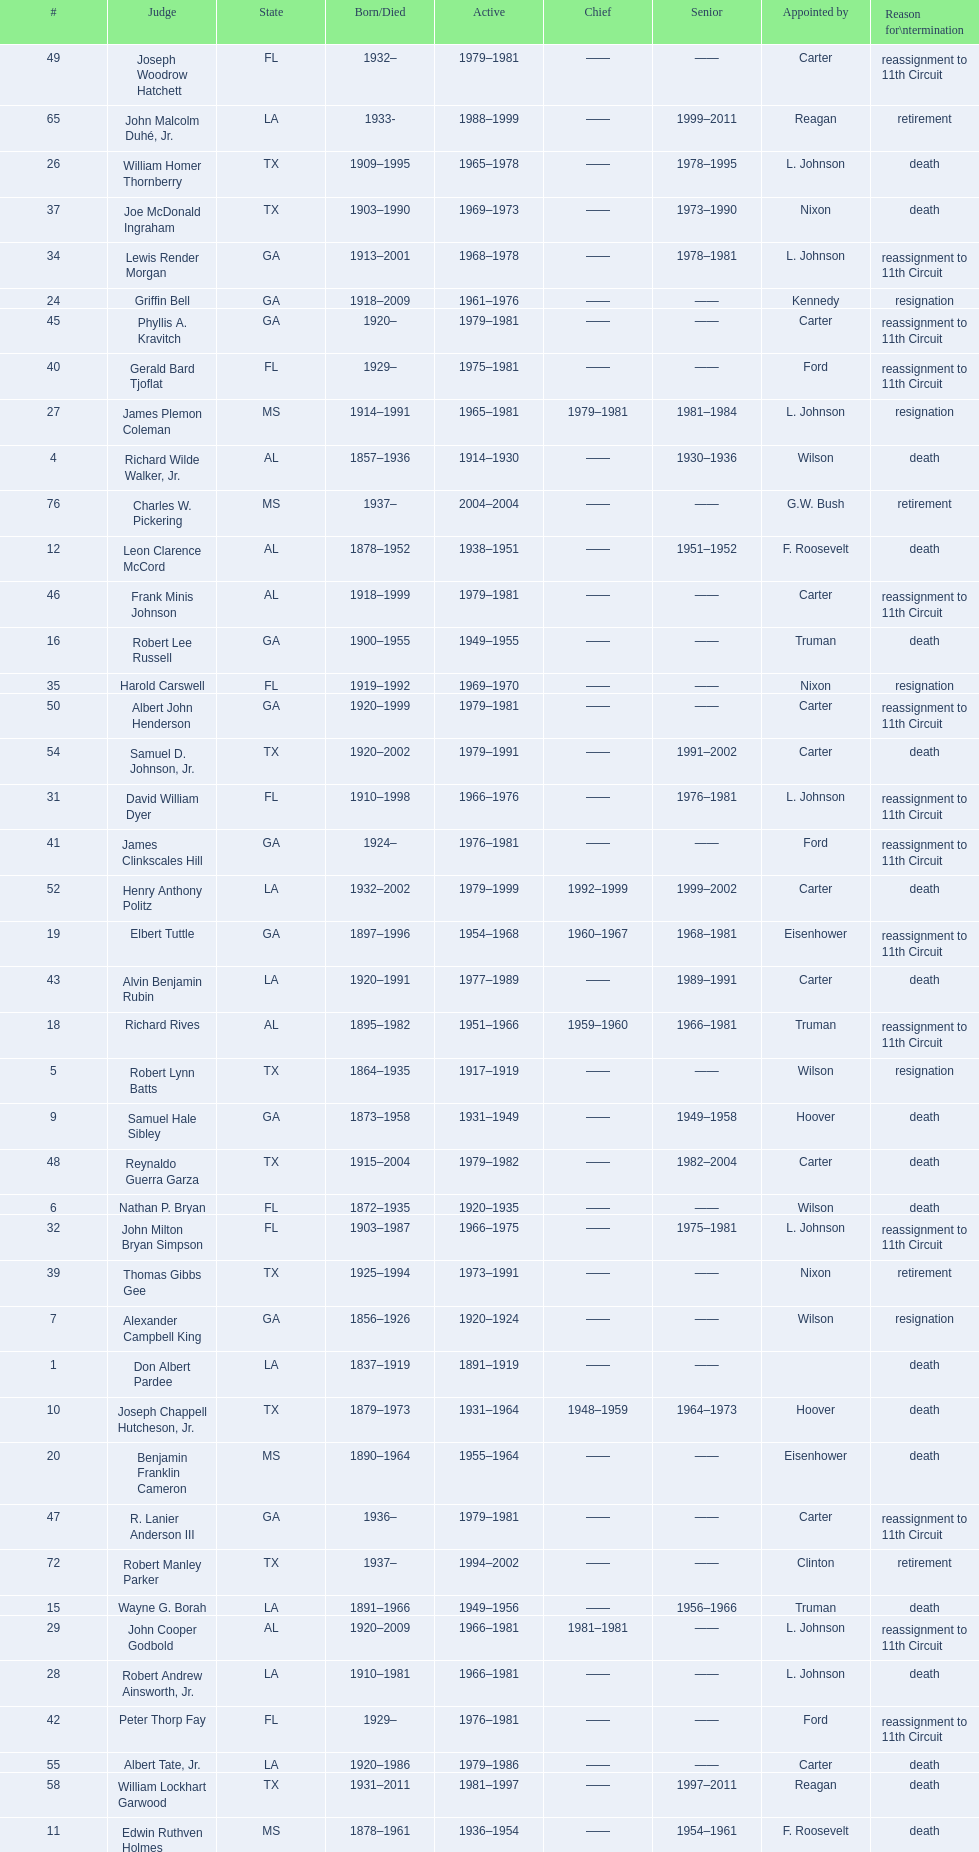Who was the first judge appointed from georgia? Alexander Campbell King. 